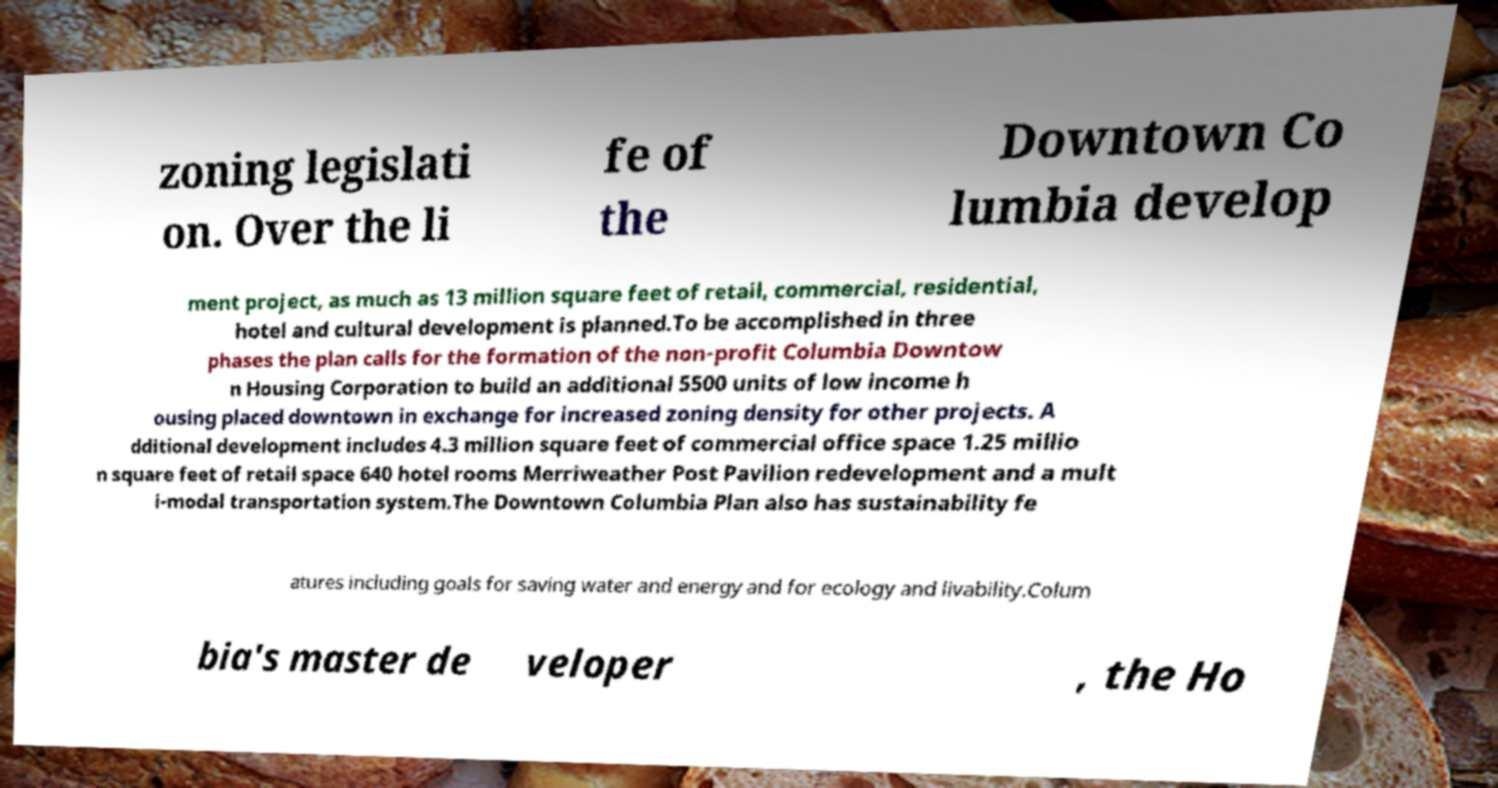What messages or text are displayed in this image? I need them in a readable, typed format. zoning legislati on. Over the li fe of the Downtown Co lumbia develop ment project, as much as 13 million square feet of retail, commercial, residential, hotel and cultural development is planned.To be accomplished in three phases the plan calls for the formation of the non-profit Columbia Downtow n Housing Corporation to build an additional 5500 units of low income h ousing placed downtown in exchange for increased zoning density for other projects. A dditional development includes 4.3 million square feet of commercial office space 1.25 millio n square feet of retail space 640 hotel rooms Merriweather Post Pavilion redevelopment and a mult i-modal transportation system.The Downtown Columbia Plan also has sustainability fe atures including goals for saving water and energy and for ecology and livability.Colum bia's master de veloper , the Ho 